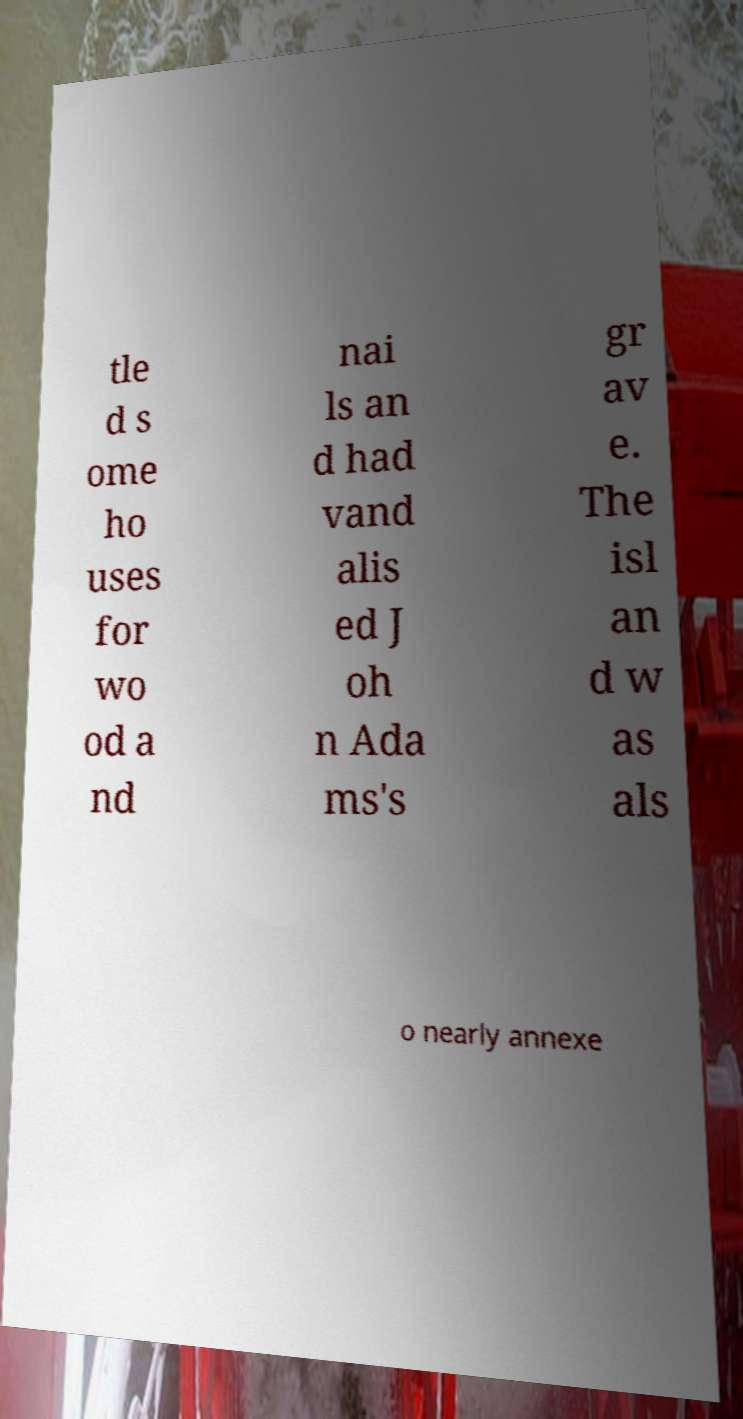Please read and relay the text visible in this image. What does it say? tle d s ome ho uses for wo od a nd nai ls an d had vand alis ed J oh n Ada ms's gr av e. The isl an d w as als o nearly annexe 